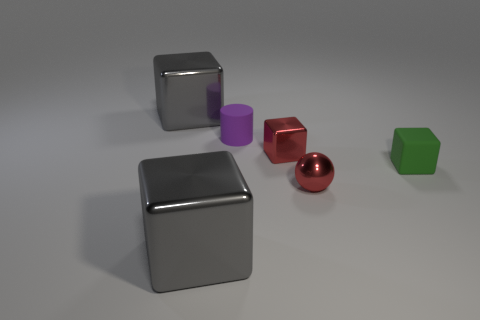There is a small object that is the same color as the tiny metal sphere; what shape is it?
Keep it short and to the point. Cube. Is the number of tiny matte blocks left of the red metallic block the same as the number of large metal cubes?
Ensure brevity in your answer.  No. Does the big cube that is in front of the small purple object have the same material as the small green cube that is on the right side of the small matte cylinder?
Your response must be concise. No. The gray shiny thing in front of the gray cube that is behind the small red metal block is what shape?
Provide a short and direct response. Cube. What color is the thing that is made of the same material as the purple cylinder?
Offer a terse response. Green. Is the color of the cylinder the same as the small metal cube?
Provide a short and direct response. No. There is a matte object that is the same size as the cylinder; what is its shape?
Ensure brevity in your answer.  Cube. The rubber cylinder has what size?
Offer a very short reply. Small. There is a shiny object right of the tiny red metallic cube; is its size the same as the gray metal cube that is in front of the cylinder?
Your answer should be very brief. No. The large cube that is in front of the large gray thing that is behind the purple thing is what color?
Keep it short and to the point. Gray. 